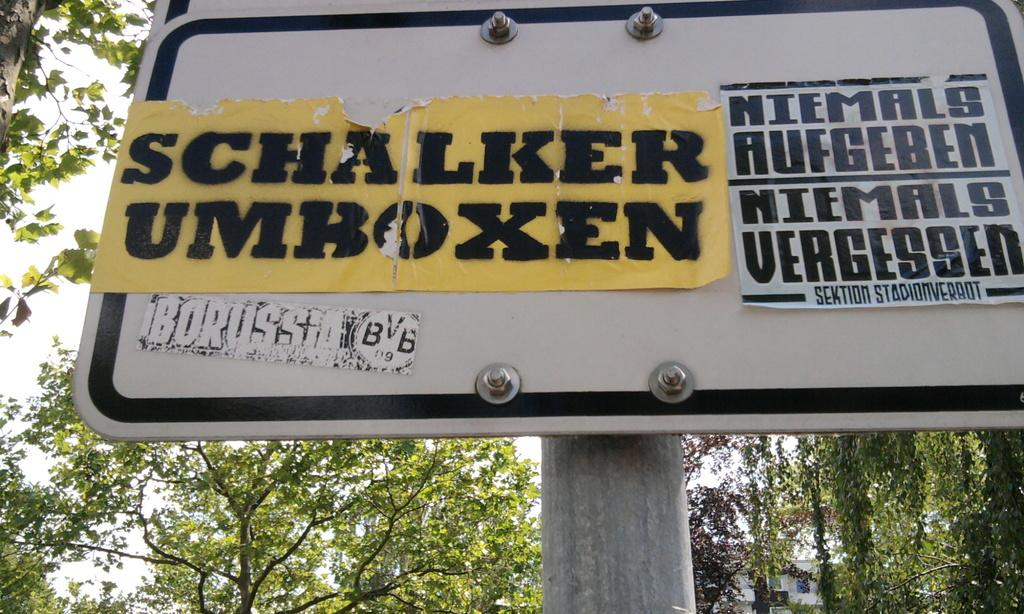What is the main object in the image? There is a board in the image. How is the board positioned? The board is on a pole. What is attached to the board? There are posts stuck on the board. What can be seen in the background of the image? Trees are visible behind the board. How many gold chairs are visible in the image? There are no gold chairs present in the image. Is there a plane flying in the background of the image? There is no plane visible in the image; only trees are present. 